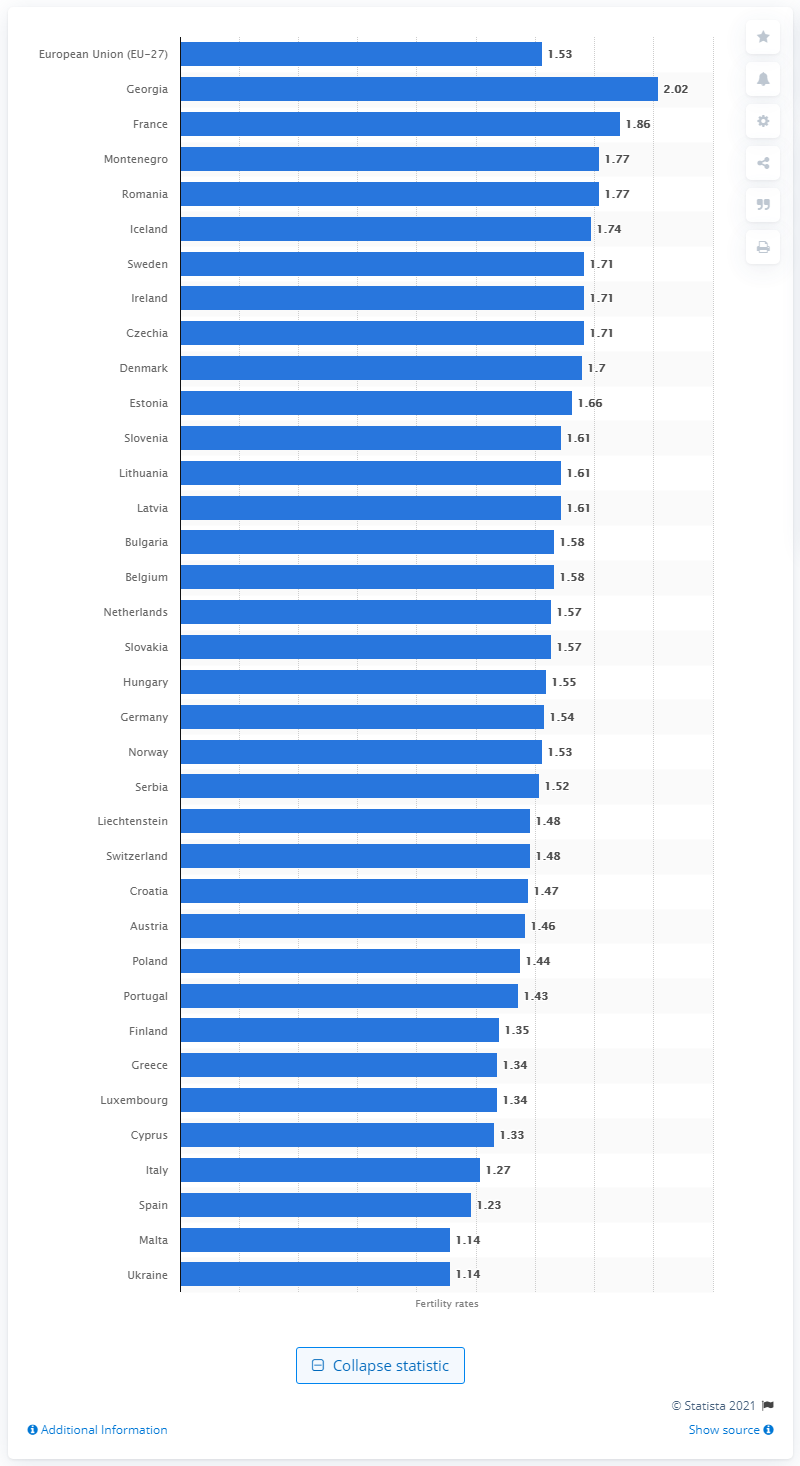Give some essential details in this illustration. In 2019, the average fertility rate in the EU-27 was 1.53 children per woman. In 2019, it was reported that approximately 2.02 children were born alive to a woman in Georgia. France's fertility rate per woman in 2019 was 1.86. 